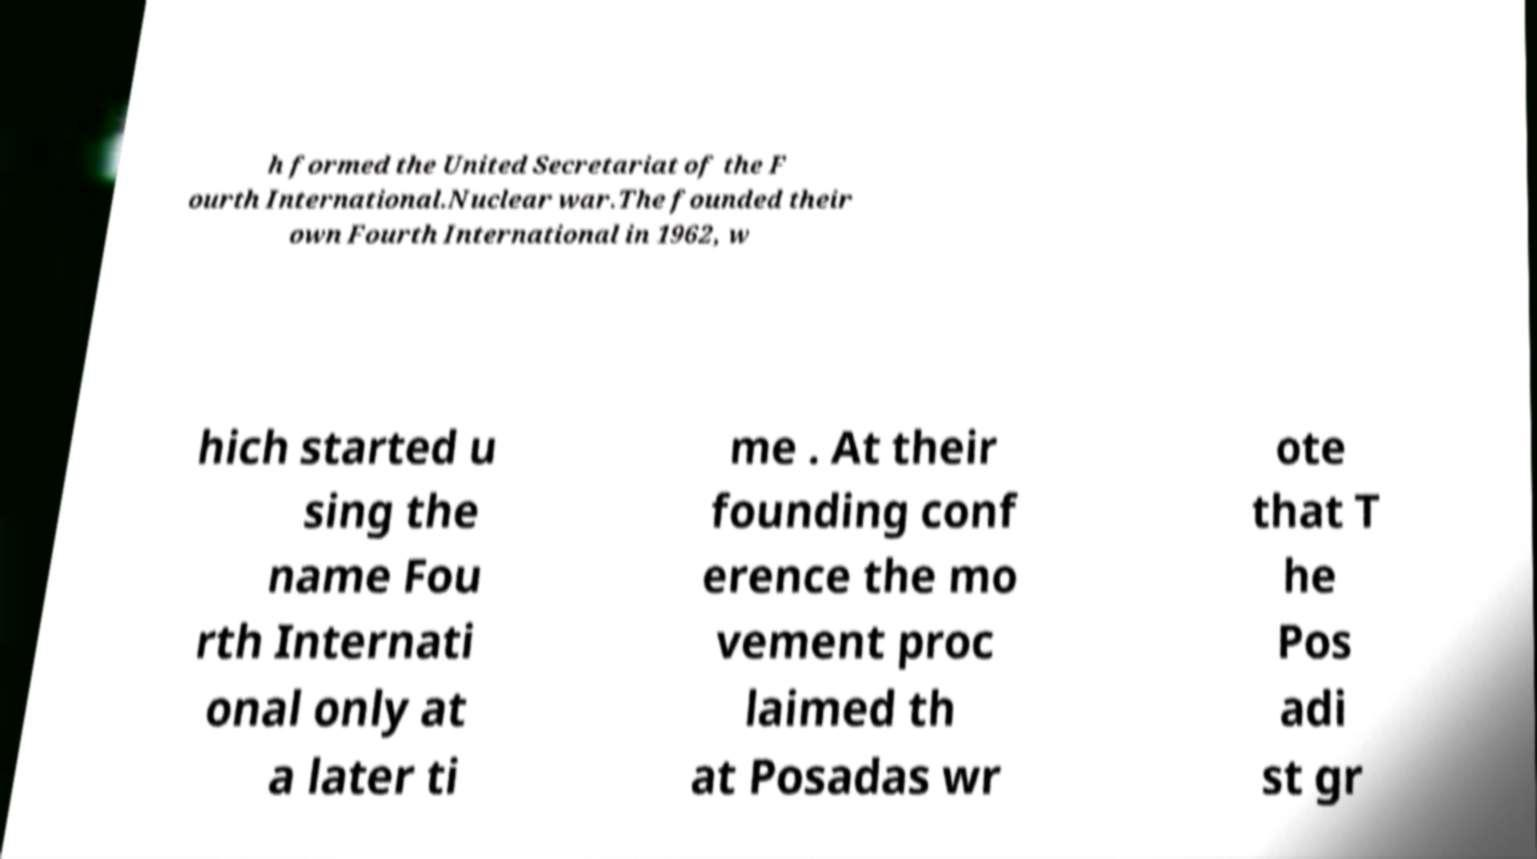Could you extract and type out the text from this image? h formed the United Secretariat of the F ourth International.Nuclear war.The founded their own Fourth International in 1962, w hich started u sing the name Fou rth Internati onal only at a later ti me . At their founding conf erence the mo vement proc laimed th at Posadas wr ote that T he Pos adi st gr 